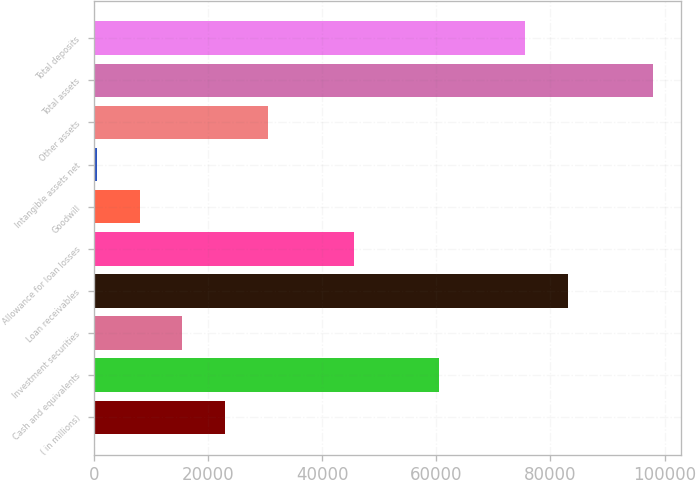<chart> <loc_0><loc_0><loc_500><loc_500><bar_chart><fcel>( in millions)<fcel>Cash and equivalents<fcel>Investment securities<fcel>Loan receivables<fcel>Allowance for loan losses<fcel>Goodwill<fcel>Intangible assets net<fcel>Other assets<fcel>Total assets<fcel>Total deposits<nl><fcel>23023.5<fcel>60531<fcel>15522<fcel>83035.5<fcel>45528<fcel>8020.5<fcel>519<fcel>30525<fcel>98038.5<fcel>75534<nl></chart> 